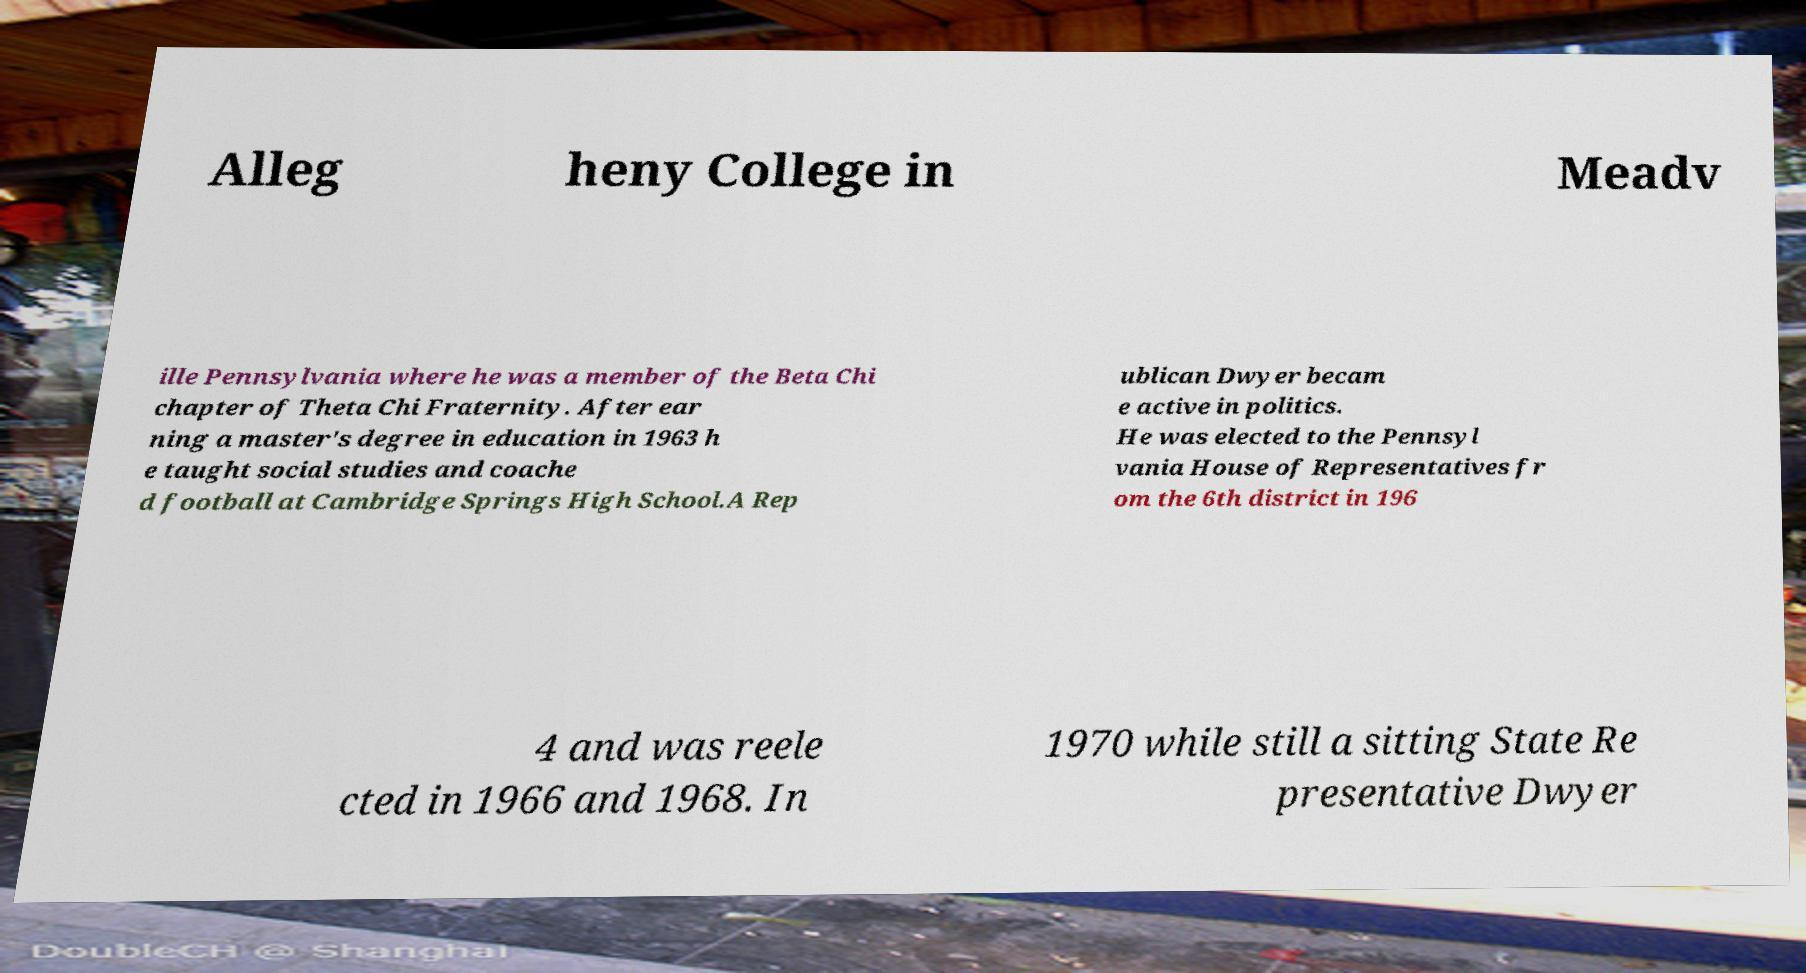There's text embedded in this image that I need extracted. Can you transcribe it verbatim? Alleg heny College in Meadv ille Pennsylvania where he was a member of the Beta Chi chapter of Theta Chi Fraternity. After ear ning a master's degree in education in 1963 h e taught social studies and coache d football at Cambridge Springs High School.A Rep ublican Dwyer becam e active in politics. He was elected to the Pennsyl vania House of Representatives fr om the 6th district in 196 4 and was reele cted in 1966 and 1968. In 1970 while still a sitting State Re presentative Dwyer 